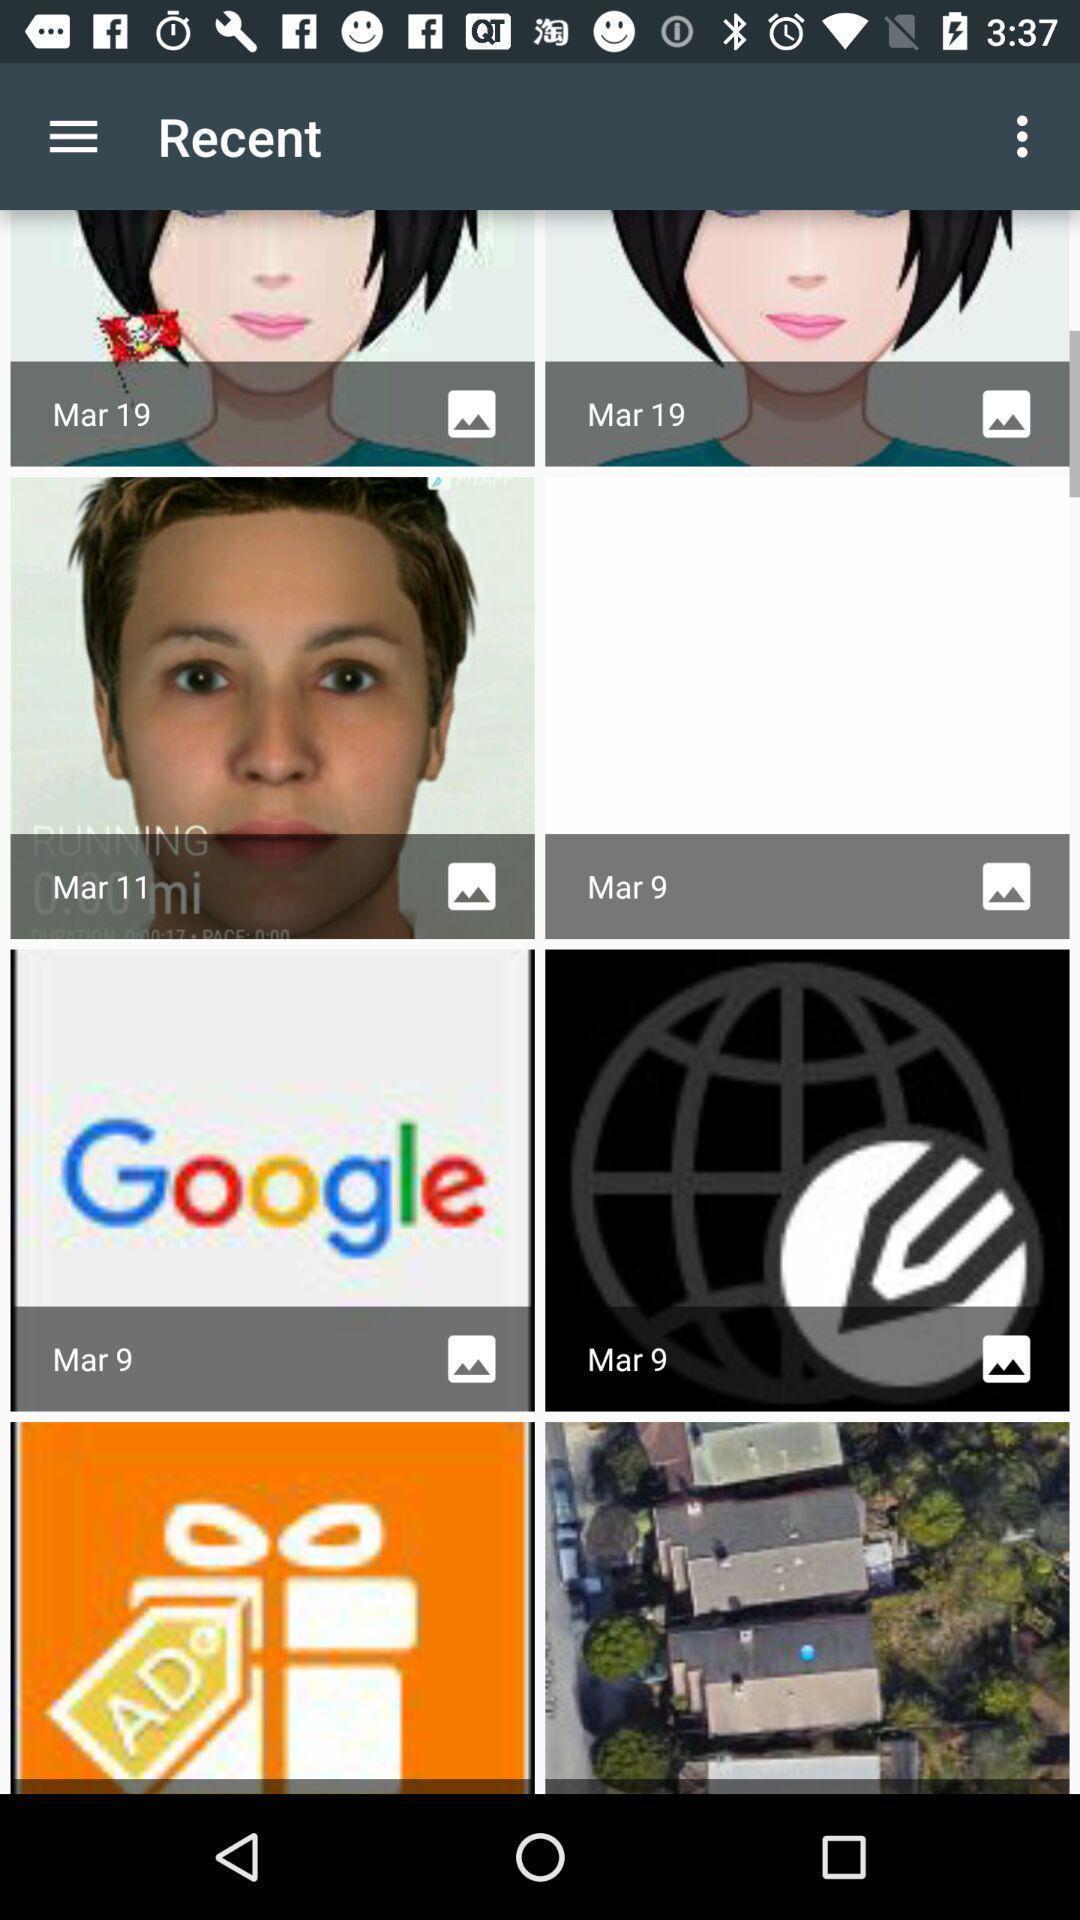Give me a summary of this screen capture. Screen displaying multiple images in a gallery. 